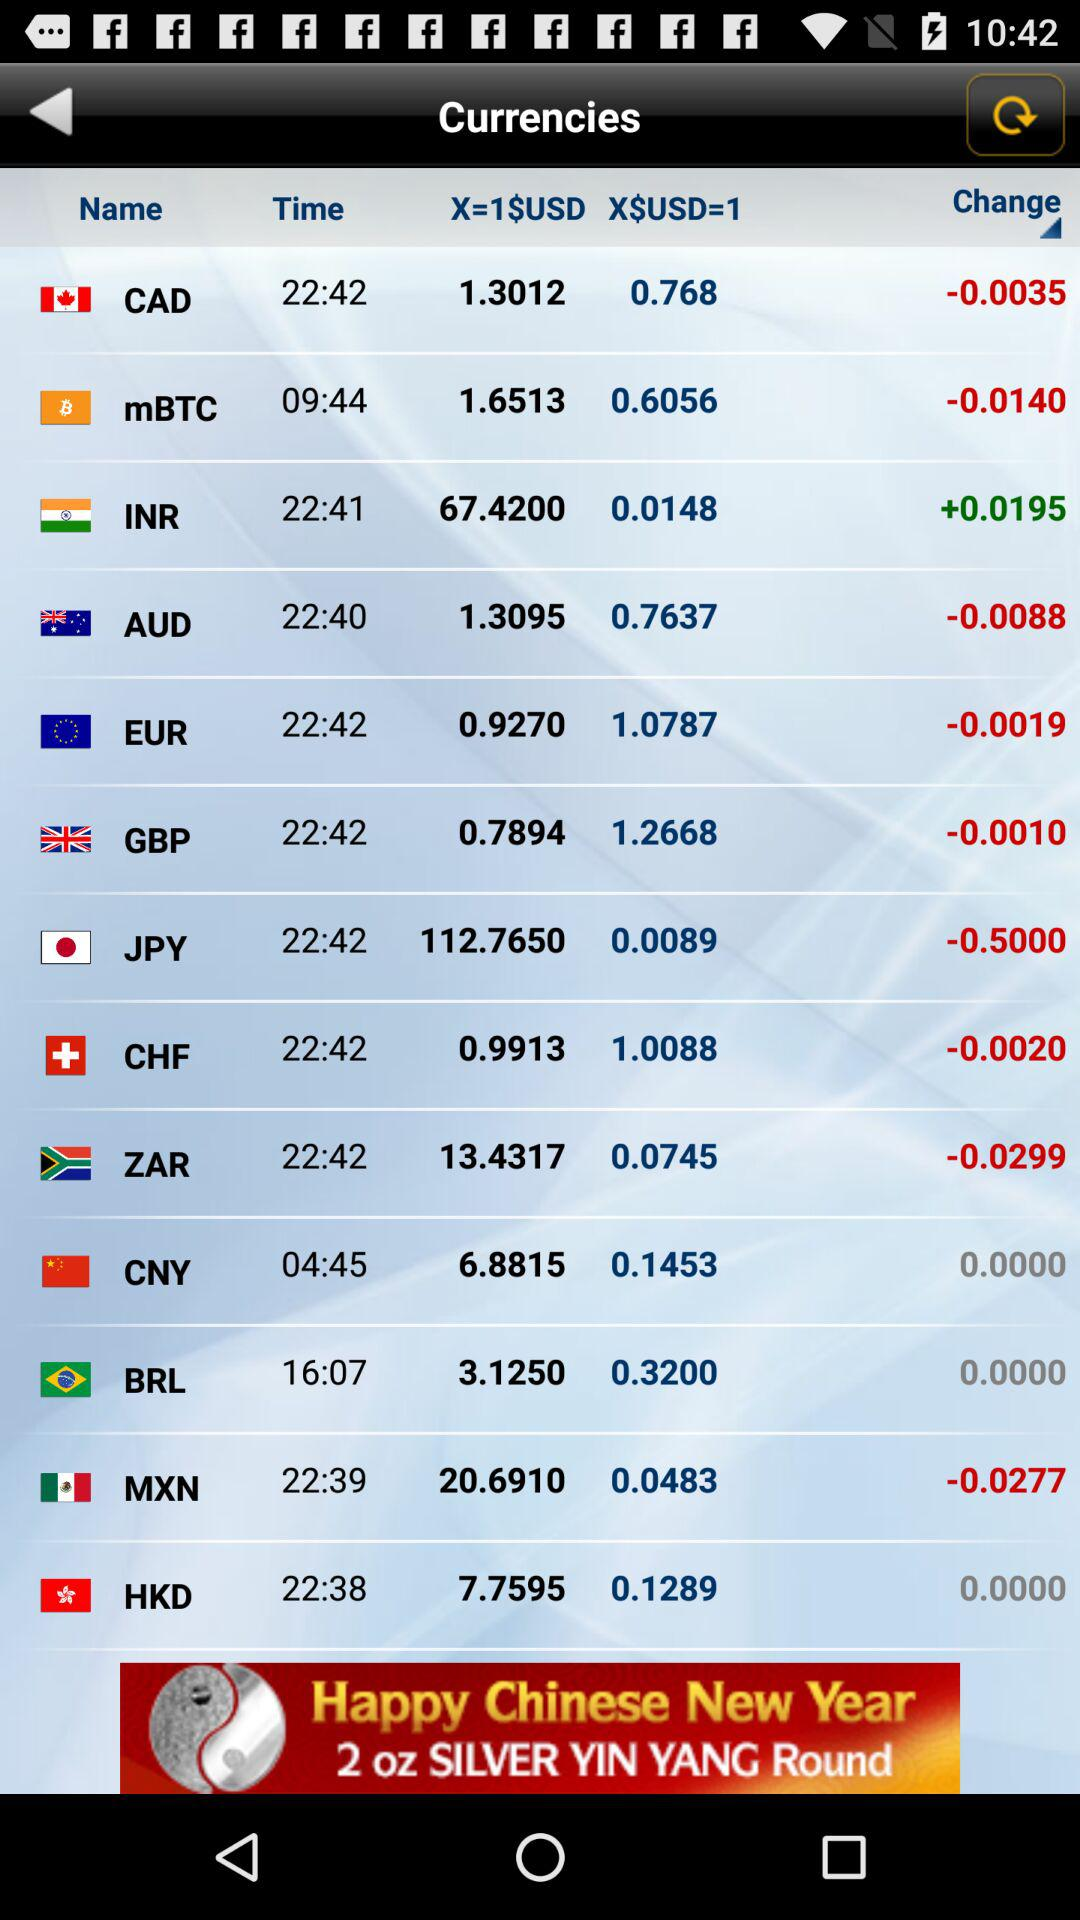How much does the USD change in AUD? The change is -0.0088. 